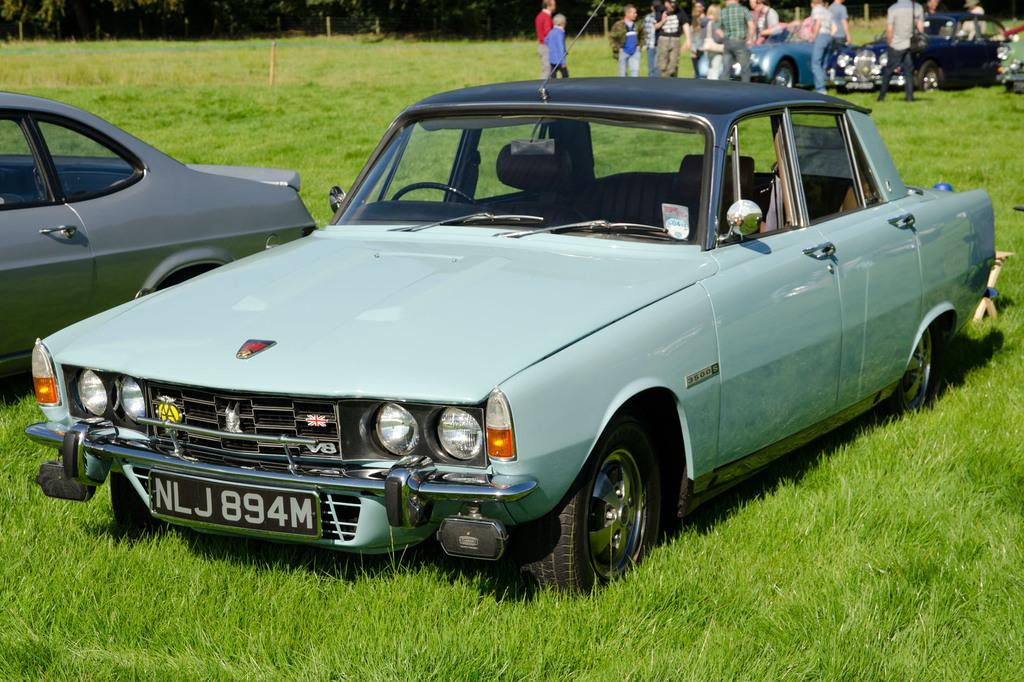What is located at the bottom of the image? There are cars on the ground at the bottom of the image. What can be seen behind the cars at the bottom of the image? There are people standing behind the cars. What is visible beyond the people in the image? There are more cars behind the people. What type of natural scenery is visible in the background of the image? There are trees visible in the background of the image. What type of waves can be seen crashing on the shore in the image? There are no waves or shore visible in the image; it features cars, people, and trees. What attraction is present in the image that people are visiting? There is no specific attraction mentioned in the image; it simply shows cars, people, and trees. 